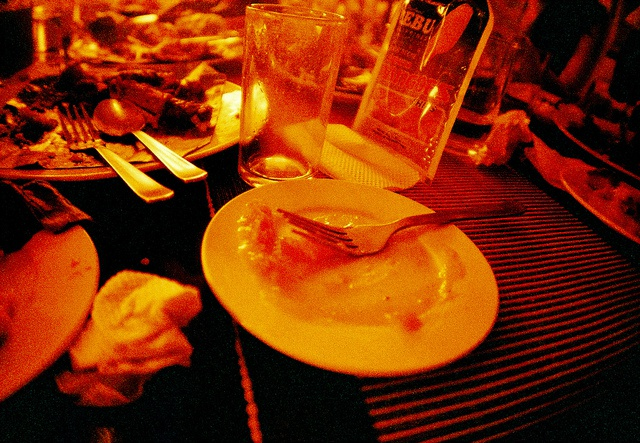Describe the objects in this image and their specific colors. I can see dining table in black, red, orange, and maroon tones, cup in black, red, orange, and brown tones, bottle in black, red, and maroon tones, cup in black, maroon, and red tones, and fork in black, red, and maroon tones in this image. 